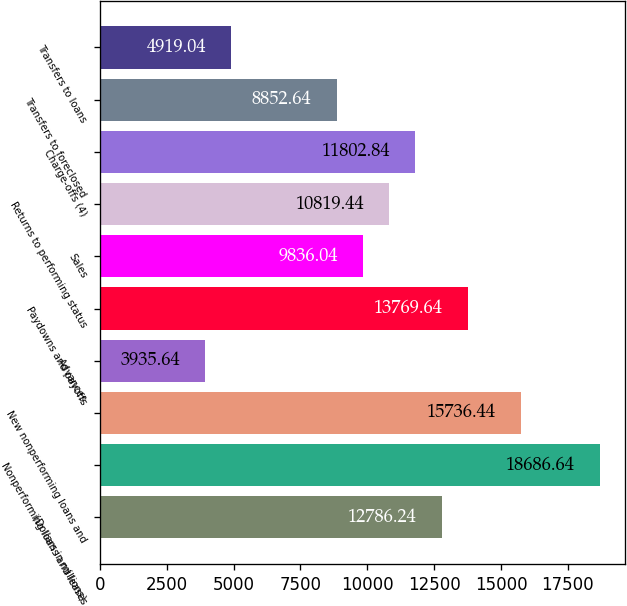<chart> <loc_0><loc_0><loc_500><loc_500><bar_chart><fcel>(Dollars in millions)<fcel>Nonperforming loans and leases<fcel>New nonperforming loans and<fcel>Advances<fcel>Paydowns and payoffs<fcel>Sales<fcel>Returns to performing status<fcel>Charge-offs (4)<fcel>Transfers to foreclosed<fcel>Transfers to loans<nl><fcel>12786.2<fcel>18686.6<fcel>15736.4<fcel>3935.64<fcel>13769.6<fcel>9836.04<fcel>10819.4<fcel>11802.8<fcel>8852.64<fcel>4919.04<nl></chart> 